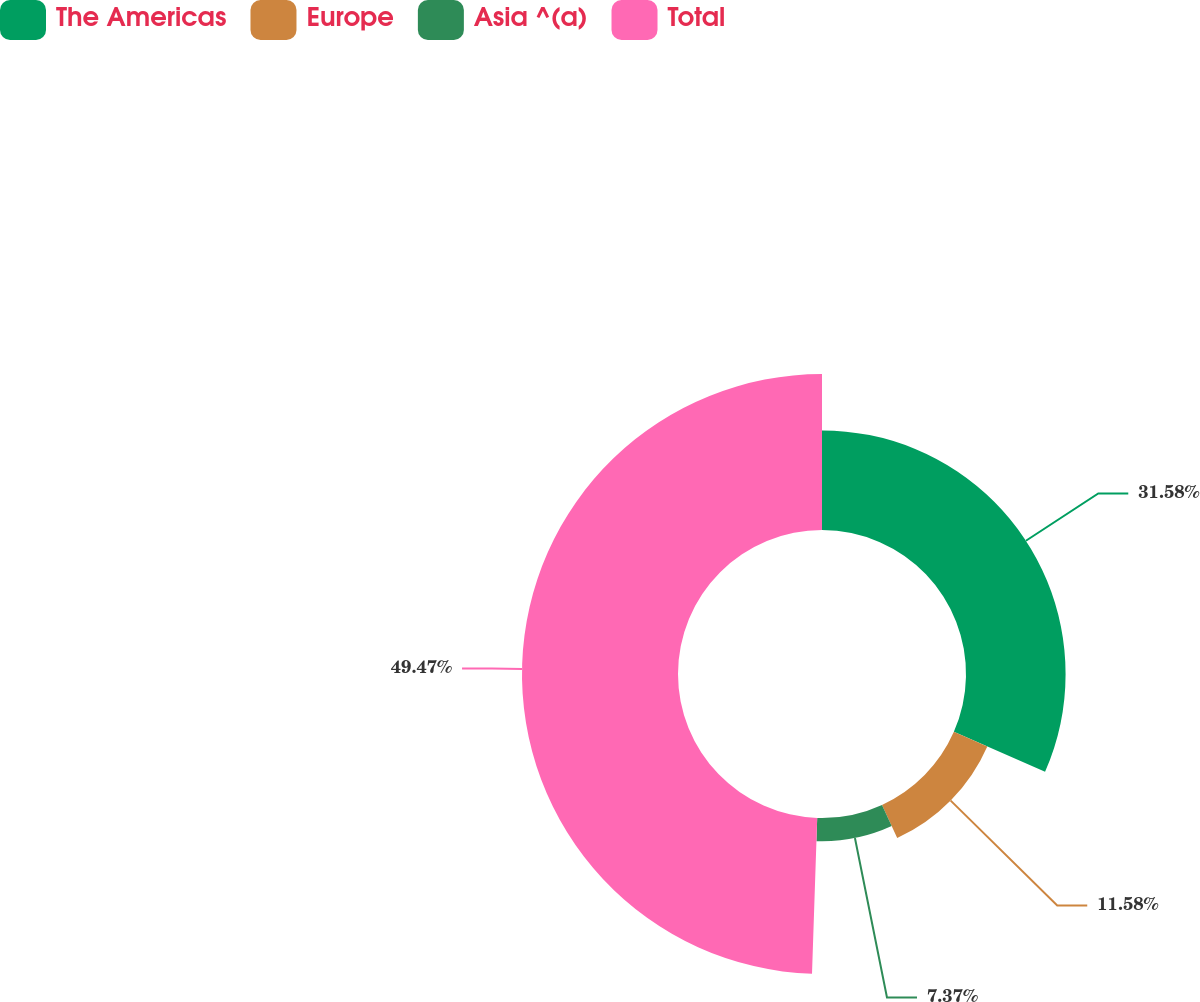Convert chart. <chart><loc_0><loc_0><loc_500><loc_500><pie_chart><fcel>The Americas<fcel>Europe<fcel>Asia ^(a)<fcel>Total<nl><fcel>31.58%<fcel>11.58%<fcel>7.37%<fcel>49.47%<nl></chart> 